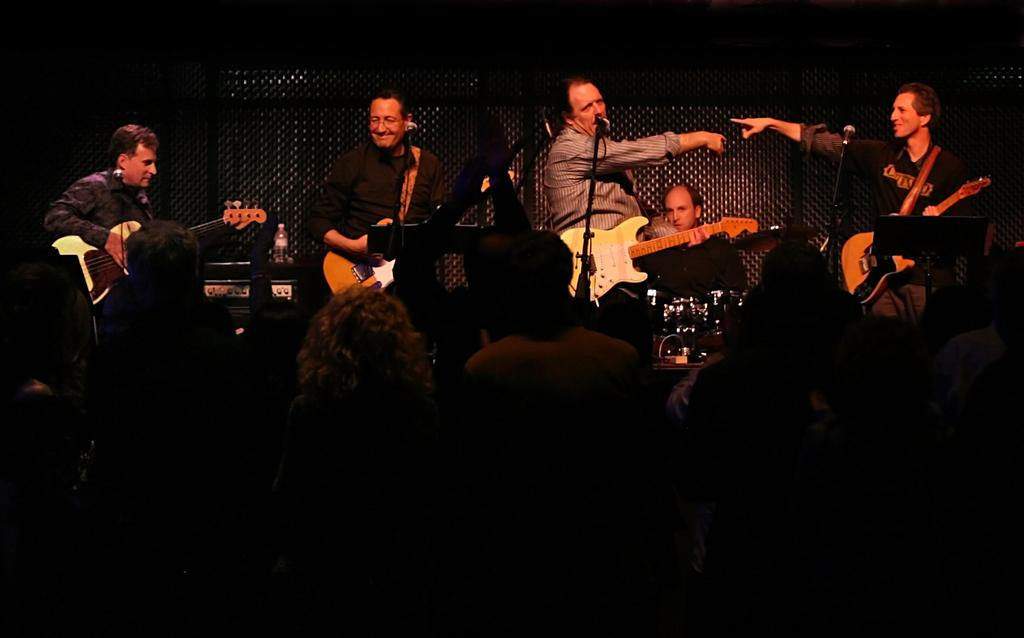What are the men in the image doing? The men in the image are playing musical instruments. What can be seen near the men? There is a microphone in the image. Who is present in the image besides the men playing instruments? There is an audience in the image. Can you describe an object related to hydration in the image? There is a water bottle on a device in the image. How many spiders are crawling on the microphone in the image? There are no spiders present in the image, and therefore no spiders are crawling on the microphone. What type of berry can be seen in the hands of the audience members? There are no berries present in the image, and no audience members are holding any berries. 